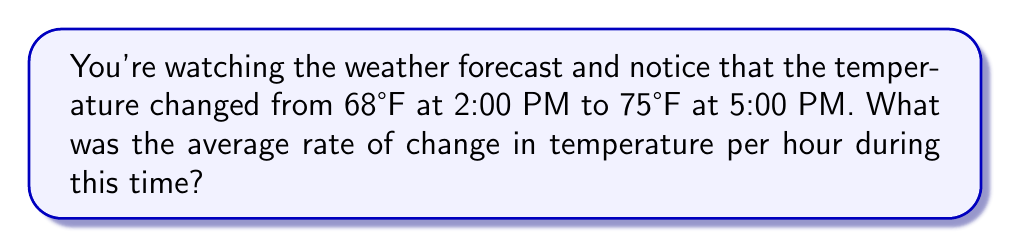Show me your answer to this math problem. Let's approach this step-by-step:

1) First, we need to identify the key information:
   - Initial temperature: 68°F at 2:00 PM
   - Final temperature: 75°F at 5:00 PM
   - Time interval: 3 hours (from 2:00 PM to 5:00 PM)

2) The rate of change formula is:
   $$ \text{Rate of Change} = \frac{\text{Change in Quantity}}{\text{Change in Time}} $$

3) Let's calculate the change in temperature:
   $$ \text{Change in Temperature} = \text{Final Temperature} - \text{Initial Temperature} $$
   $$ \text{Change in Temperature} = 75°F - 68°F = 7°F $$

4) We know the change in time is 3 hours.

5) Now, let's apply the rate of change formula:
   $$ \text{Rate of Change} = \frac{7°F}{3 \text{ hours}} $$

6) Simplify the fraction:
   $$ \text{Rate of Change} = \frac{7}{3}°F/\text{hour} \approx 2.33°F/\text{hour} $$

Therefore, the average rate of change in temperature was about 2.33°F per hour.
Answer: $\frac{7}{3}°F/\text{hour}$ or $2.33°F/\text{hour}$ 